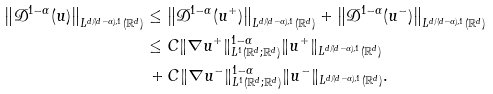<formula> <loc_0><loc_0><loc_500><loc_500>\left \| \mathcal { D } ^ { 1 - \alpha } ( u ) \right \| _ { L ^ { d / ( d - \alpha ) , 1 } ( \mathbb { R } ^ { d } ) } & \leq \left \| \mathcal { D } ^ { 1 - \alpha } ( u ^ { + } ) \right \| _ { L ^ { d / ( d - \alpha ) , 1 } ( \mathbb { R } ^ { d } ) } + \left \| \mathcal { D } ^ { 1 - \alpha } ( u ^ { - } ) \right \| _ { L ^ { d / ( d - \alpha ) , 1 } ( \mathbb { R } ^ { d } ) } \\ & \leq C \| \nabla u ^ { + } \| ^ { 1 - \alpha } _ { L ^ { 1 } ( \mathbb { R } ^ { d } ; \mathbb { R } ^ { d } ) } \| u ^ { + } \| _ { L ^ { d / ( d - \alpha ) , 1 } ( \mathbb { R } ^ { d } ) } \\ & \, + C \| \nabla u ^ { - } \| ^ { 1 - \alpha } _ { L ^ { 1 } ( \mathbb { R } ^ { d } ; \mathbb { R } ^ { d } ) } \| u ^ { - } \| _ { L ^ { d / ( d - \alpha ) , 1 } ( \mathbb { R } ^ { d } ) } .</formula> 